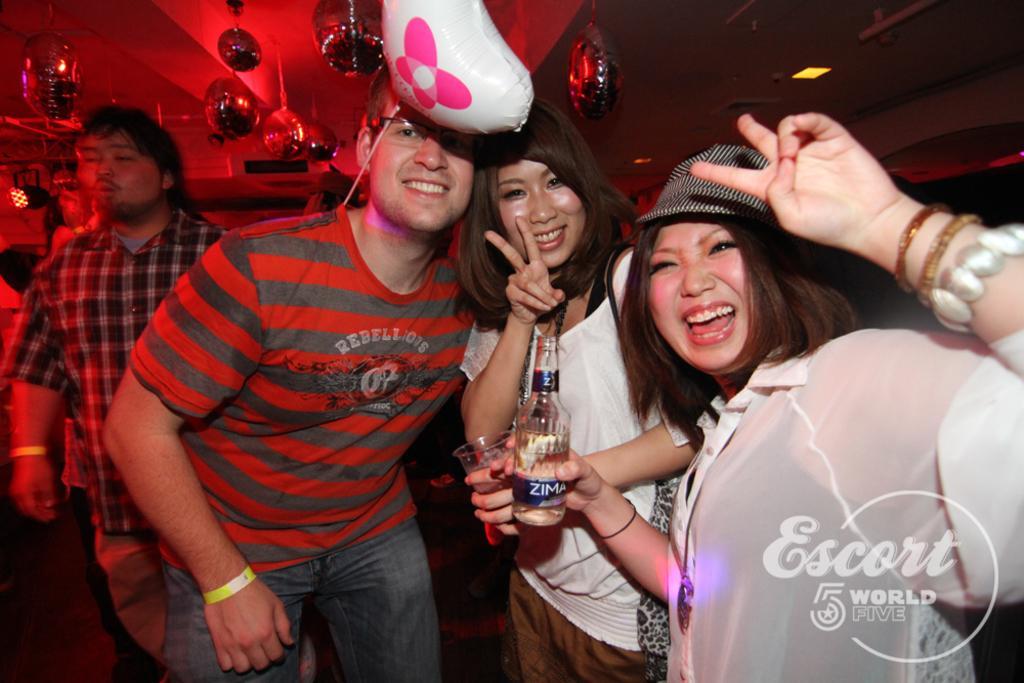How would you summarize this image in a sentence or two? This image consists of so many persons in the middle. There are two persons who are holding a glass and a bottle. There is a balloon at the top. There are lights at the top. 